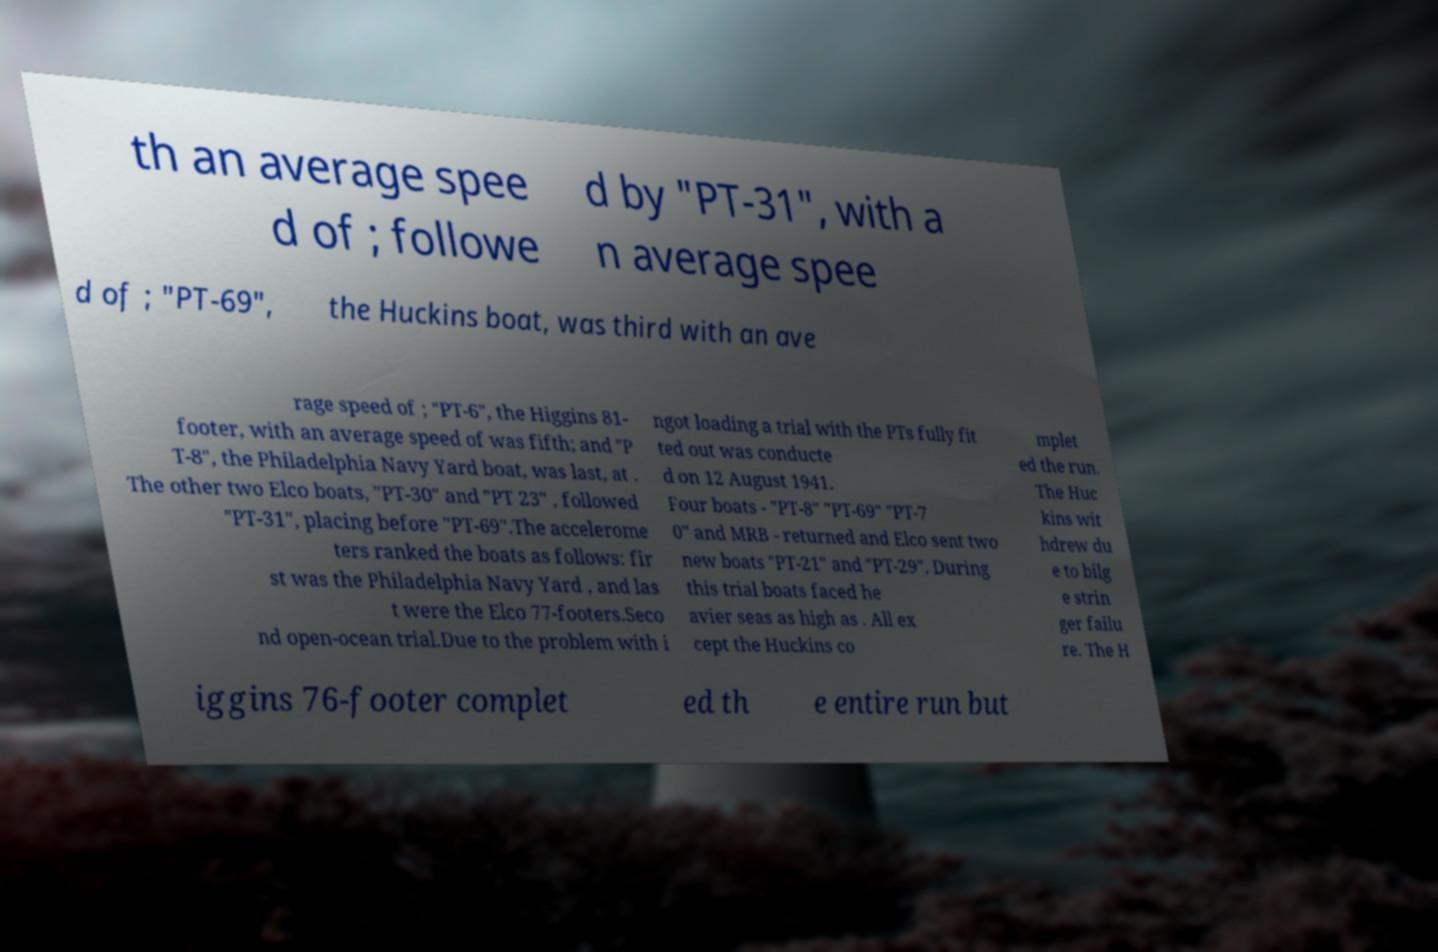Can you accurately transcribe the text from the provided image for me? th an average spee d of ; followe d by "PT-31", with a n average spee d of ; "PT-69", the Huckins boat, was third with an ave rage speed of ; "PT-6", the Higgins 81- footer, with an average speed of was fifth; and "P T-8", the Philadelphia Navy Yard boat, was last, at . The other two Elco boats, "PT-30" and "PT 23" , followed "PT-31", placing before "PT-69".The accelerome ters ranked the boats as follows: fir st was the Philadelphia Navy Yard , and las t were the Elco 77-footers.Seco nd open-ocean trial.Due to the problem with i ngot loading a trial with the PTs fully fit ted out was conducte d on 12 August 1941. Four boats - "PT-8" "PT-69" "PT-7 0" and MRB - returned and Elco sent two new boats "PT-21" and "PT-29". During this trial boats faced he avier seas as high as . All ex cept the Huckins co mplet ed the run. The Huc kins wit hdrew du e to bilg e strin ger failu re. The H iggins 76-footer complet ed th e entire run but 